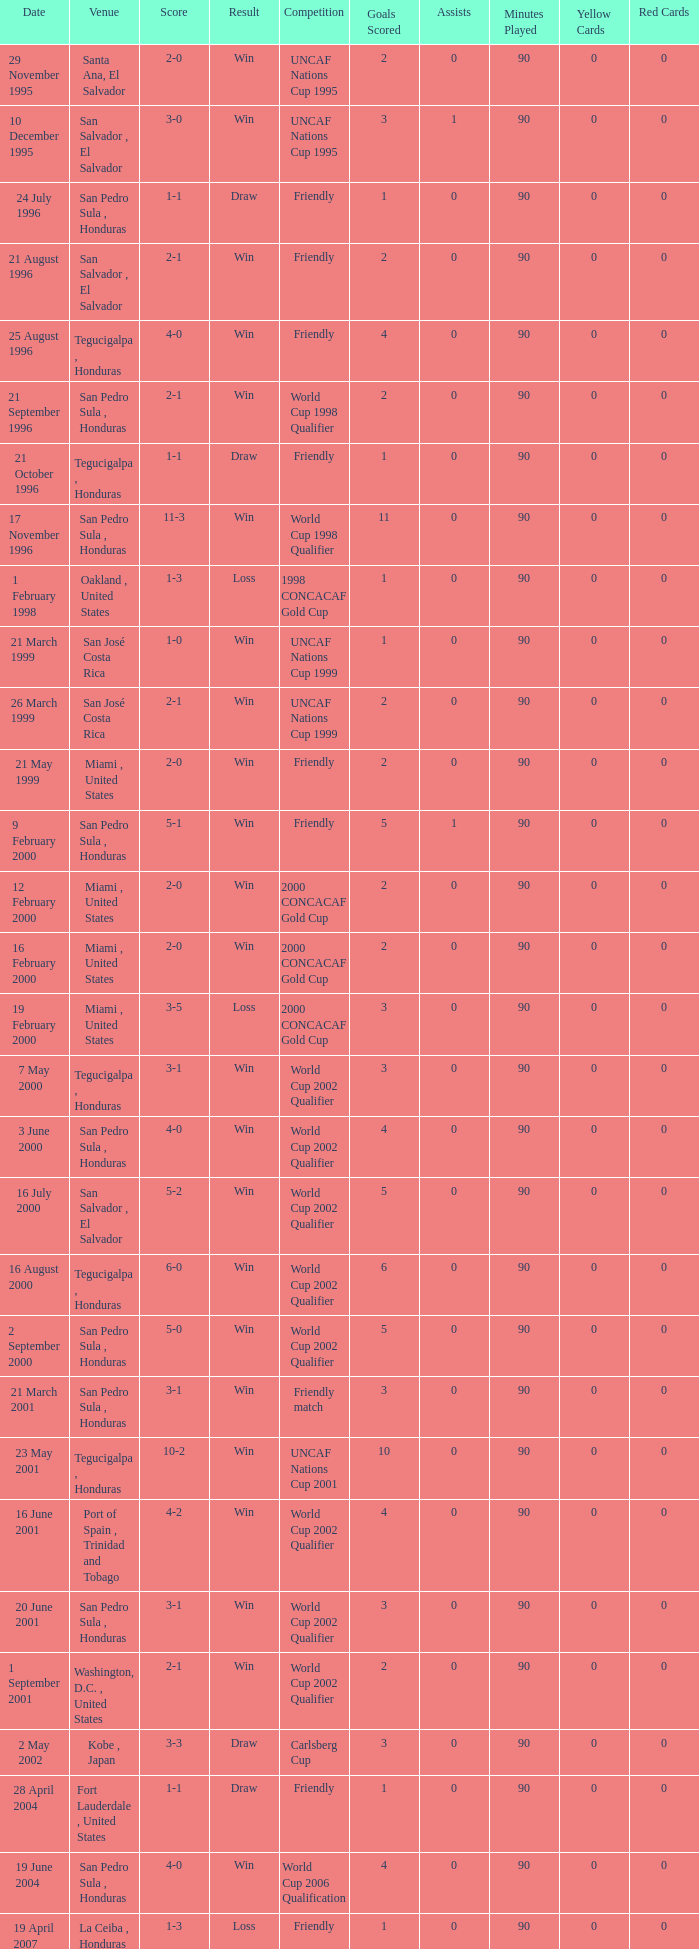Name the date of the uncaf nations cup 2009 26 January 2009. 